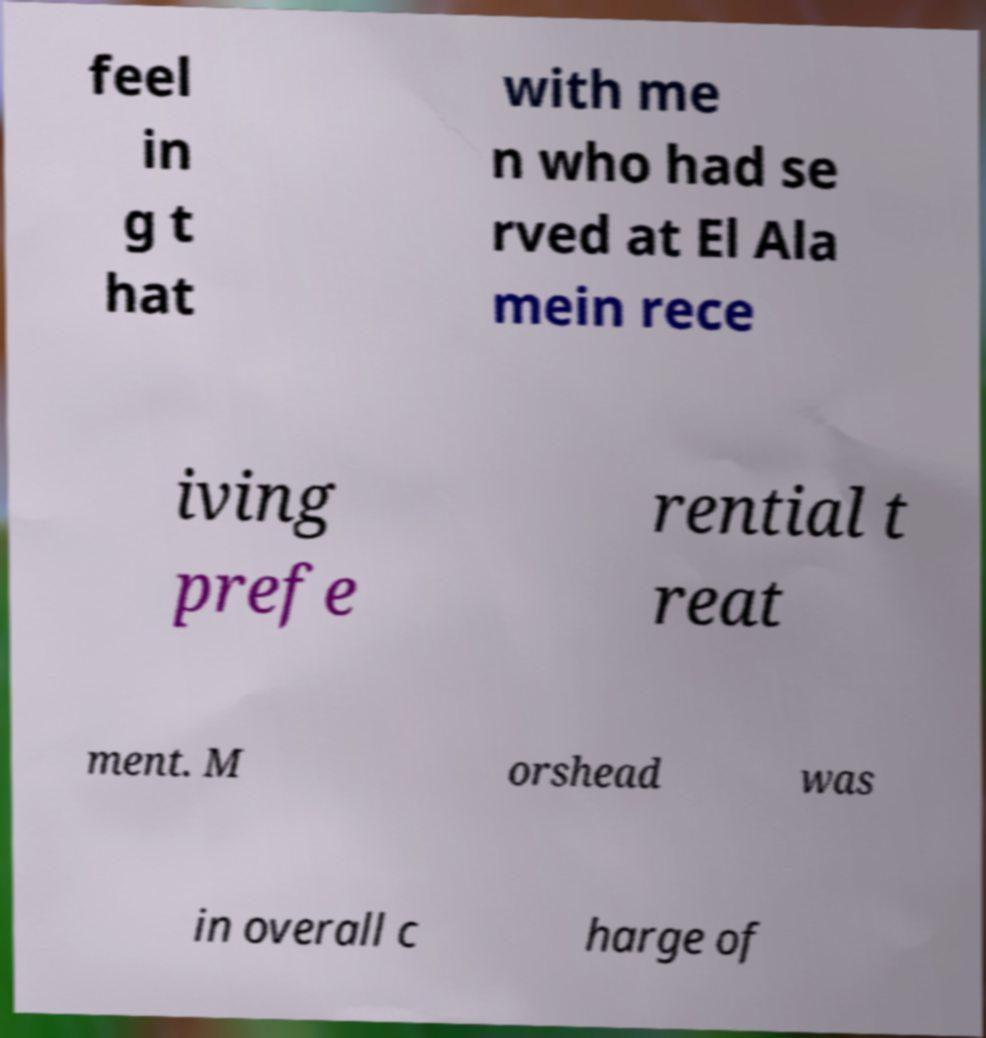What messages or text are displayed in this image? I need them in a readable, typed format. feel in g t hat with me n who had se rved at El Ala mein rece iving prefe rential t reat ment. M orshead was in overall c harge of 